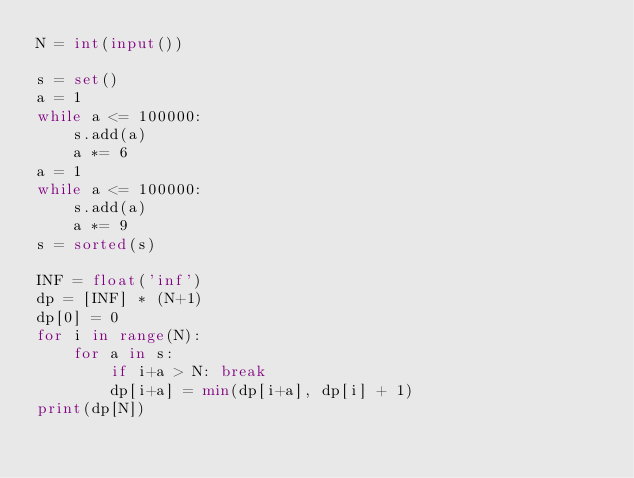<code> <loc_0><loc_0><loc_500><loc_500><_Python_>N = int(input())

s = set()
a = 1
while a <= 100000:
    s.add(a)
    a *= 6
a = 1
while a <= 100000:
    s.add(a)
    a *= 9
s = sorted(s)

INF = float('inf')
dp = [INF] * (N+1)
dp[0] = 0
for i in range(N):
    for a in s:
        if i+a > N: break
        dp[i+a] = min(dp[i+a], dp[i] + 1)
print(dp[N])</code> 